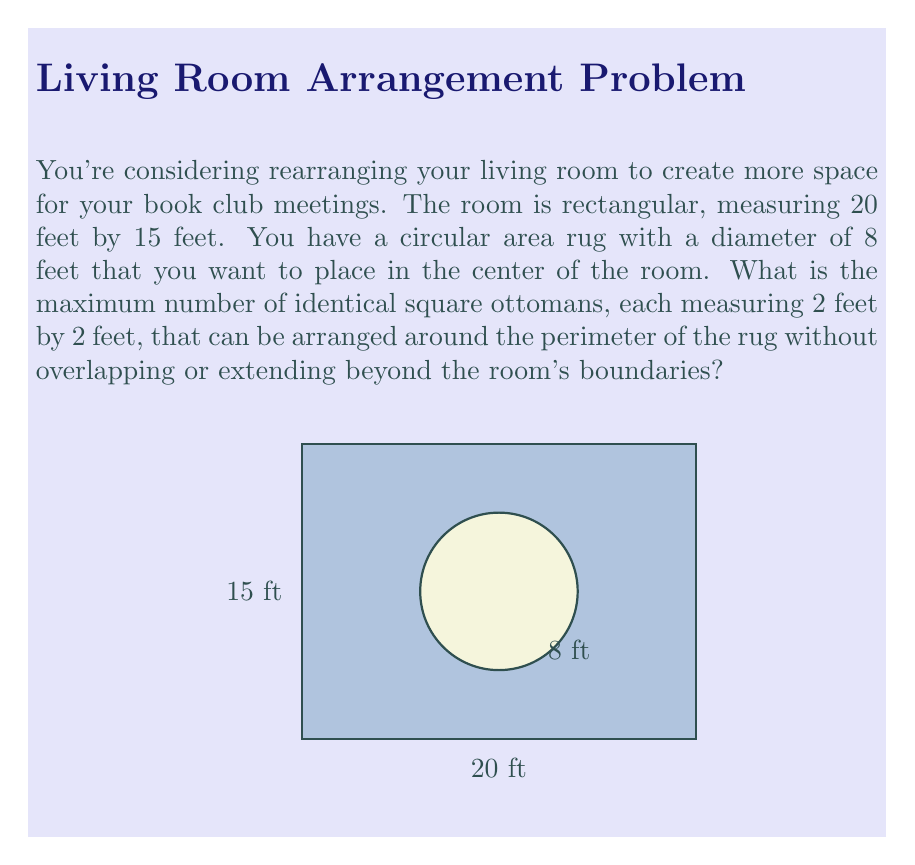Teach me how to tackle this problem. Let's approach this step-by-step:

1) First, we need to calculate the circumference of the rug:
   $C = \pi d = \pi \cdot 8 = 8\pi$ feet

2) Each ottoman is 2 feet wide, so we need to determine how many 2-foot segments can fit around the rug:
   $N = \lfloor \frac{8\pi}{2} \rfloor = \lfloor 4\pi \rfloor = 12$

   We use the floor function because we can only have whole ottomans.

3) Now, we need to check if these 12 ottomans will fit within the room's boundaries:

   The rug is centered in the room, so there are:
   - $(20 - 8)/2 = 6$ feet on each side of the rug (length-wise)
   - $(15 - 8)/2 = 3.5$ feet on each side of the rug (width-wise)

4) We can fit 3 ottomans (2 feet each) on each long side, and 1 ottoman on each short side:
   $3 + 3 + 1 + 1 = 8$ ottomans

5) The remaining space is:
   - Length-wise: $6 - (3 \cdot 2) = 0$ feet on each side
   - Width-wise: $3.5 - 2 = 1.5$ feet on each side

6) There's enough space for 2 more ottomans on each of the shorter sides:
   $8 + 2 + 2 = 12$ ottomans in total

This matches our calculation from step 2, confirming that 12 is indeed the maximum number of ottomans that can fit.
Answer: 12 ottomans 